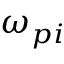Convert formula to latex. <formula><loc_0><loc_0><loc_500><loc_500>\omega _ { p i }</formula> 